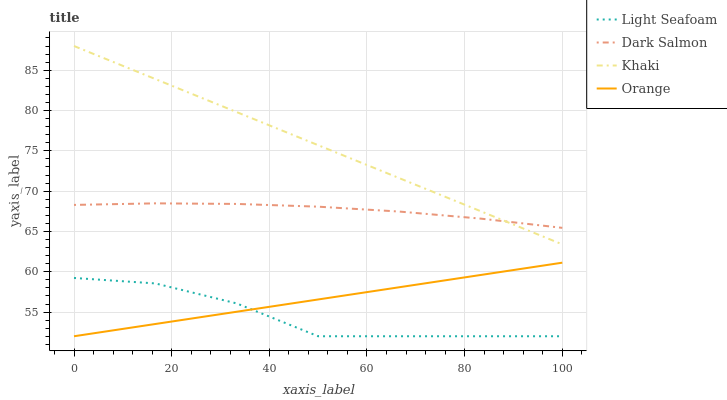Does Light Seafoam have the minimum area under the curve?
Answer yes or no. Yes. Does Khaki have the maximum area under the curve?
Answer yes or no. Yes. Does Khaki have the minimum area under the curve?
Answer yes or no. No. Does Light Seafoam have the maximum area under the curve?
Answer yes or no. No. Is Khaki the smoothest?
Answer yes or no. Yes. Is Light Seafoam the roughest?
Answer yes or no. Yes. Is Light Seafoam the smoothest?
Answer yes or no. No. Is Khaki the roughest?
Answer yes or no. No. Does Orange have the lowest value?
Answer yes or no. Yes. Does Khaki have the lowest value?
Answer yes or no. No. Does Khaki have the highest value?
Answer yes or no. Yes. Does Light Seafoam have the highest value?
Answer yes or no. No. Is Orange less than Khaki?
Answer yes or no. Yes. Is Dark Salmon greater than Light Seafoam?
Answer yes or no. Yes. Does Orange intersect Light Seafoam?
Answer yes or no. Yes. Is Orange less than Light Seafoam?
Answer yes or no. No. Is Orange greater than Light Seafoam?
Answer yes or no. No. Does Orange intersect Khaki?
Answer yes or no. No. 